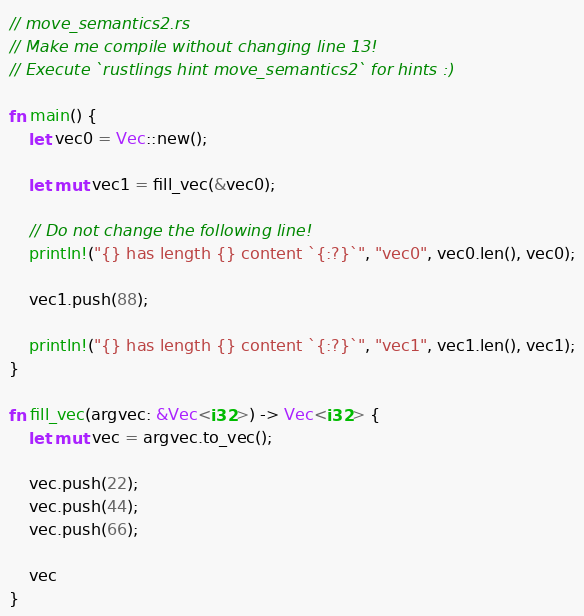Convert code to text. <code><loc_0><loc_0><loc_500><loc_500><_Rust_>// move_semantics2.rs
// Make me compile without changing line 13!
// Execute `rustlings hint move_semantics2` for hints :)

fn main() {
    let vec0 = Vec::new();

    let mut vec1 = fill_vec(&vec0);

    // Do not change the following line!
    println!("{} has length {} content `{:?}`", "vec0", vec0.len(), vec0);

    vec1.push(88);

    println!("{} has length {} content `{:?}`", "vec1", vec1.len(), vec1);
}

fn fill_vec(argvec: &Vec<i32>) -> Vec<i32> {
    let mut vec = argvec.to_vec();

    vec.push(22);
    vec.push(44);
    vec.push(66);

    vec
}
</code> 